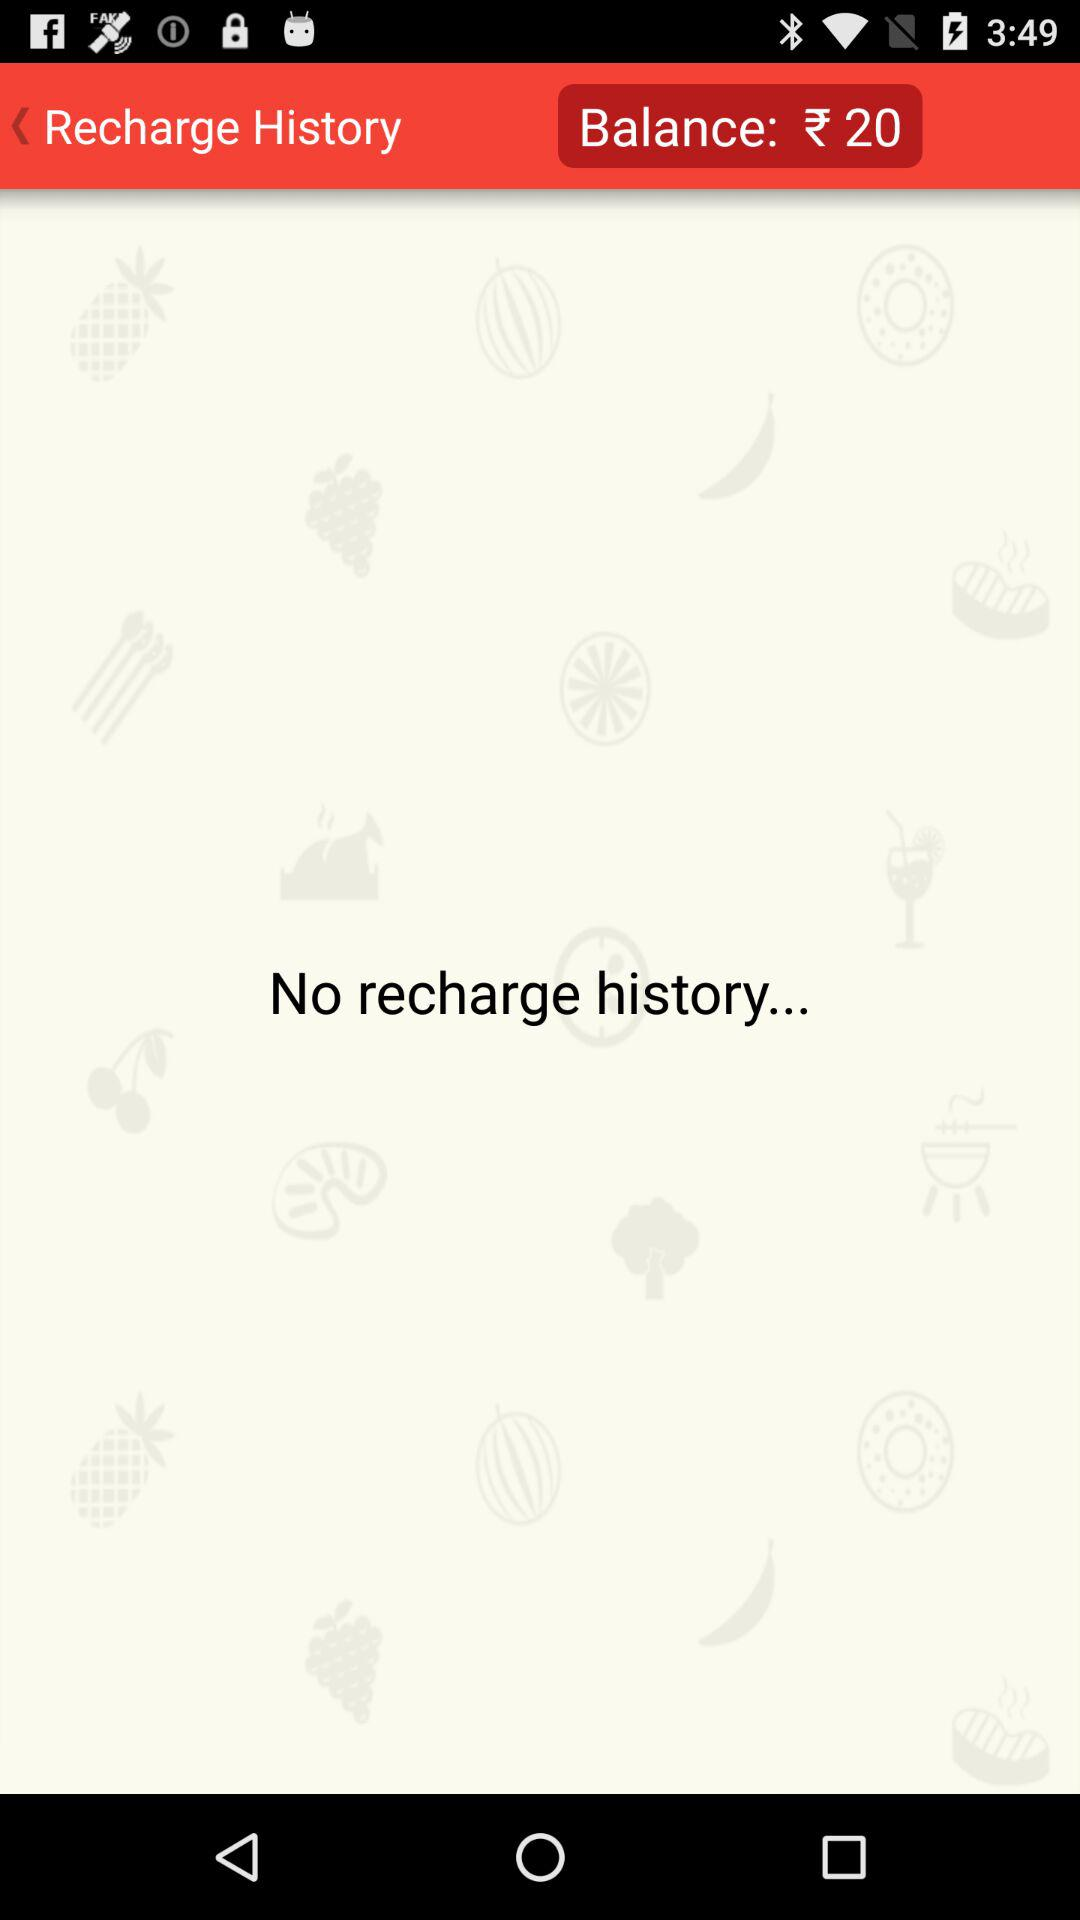Who is this application powered by?
When the provided information is insufficient, respond with <no answer>. <no answer> 